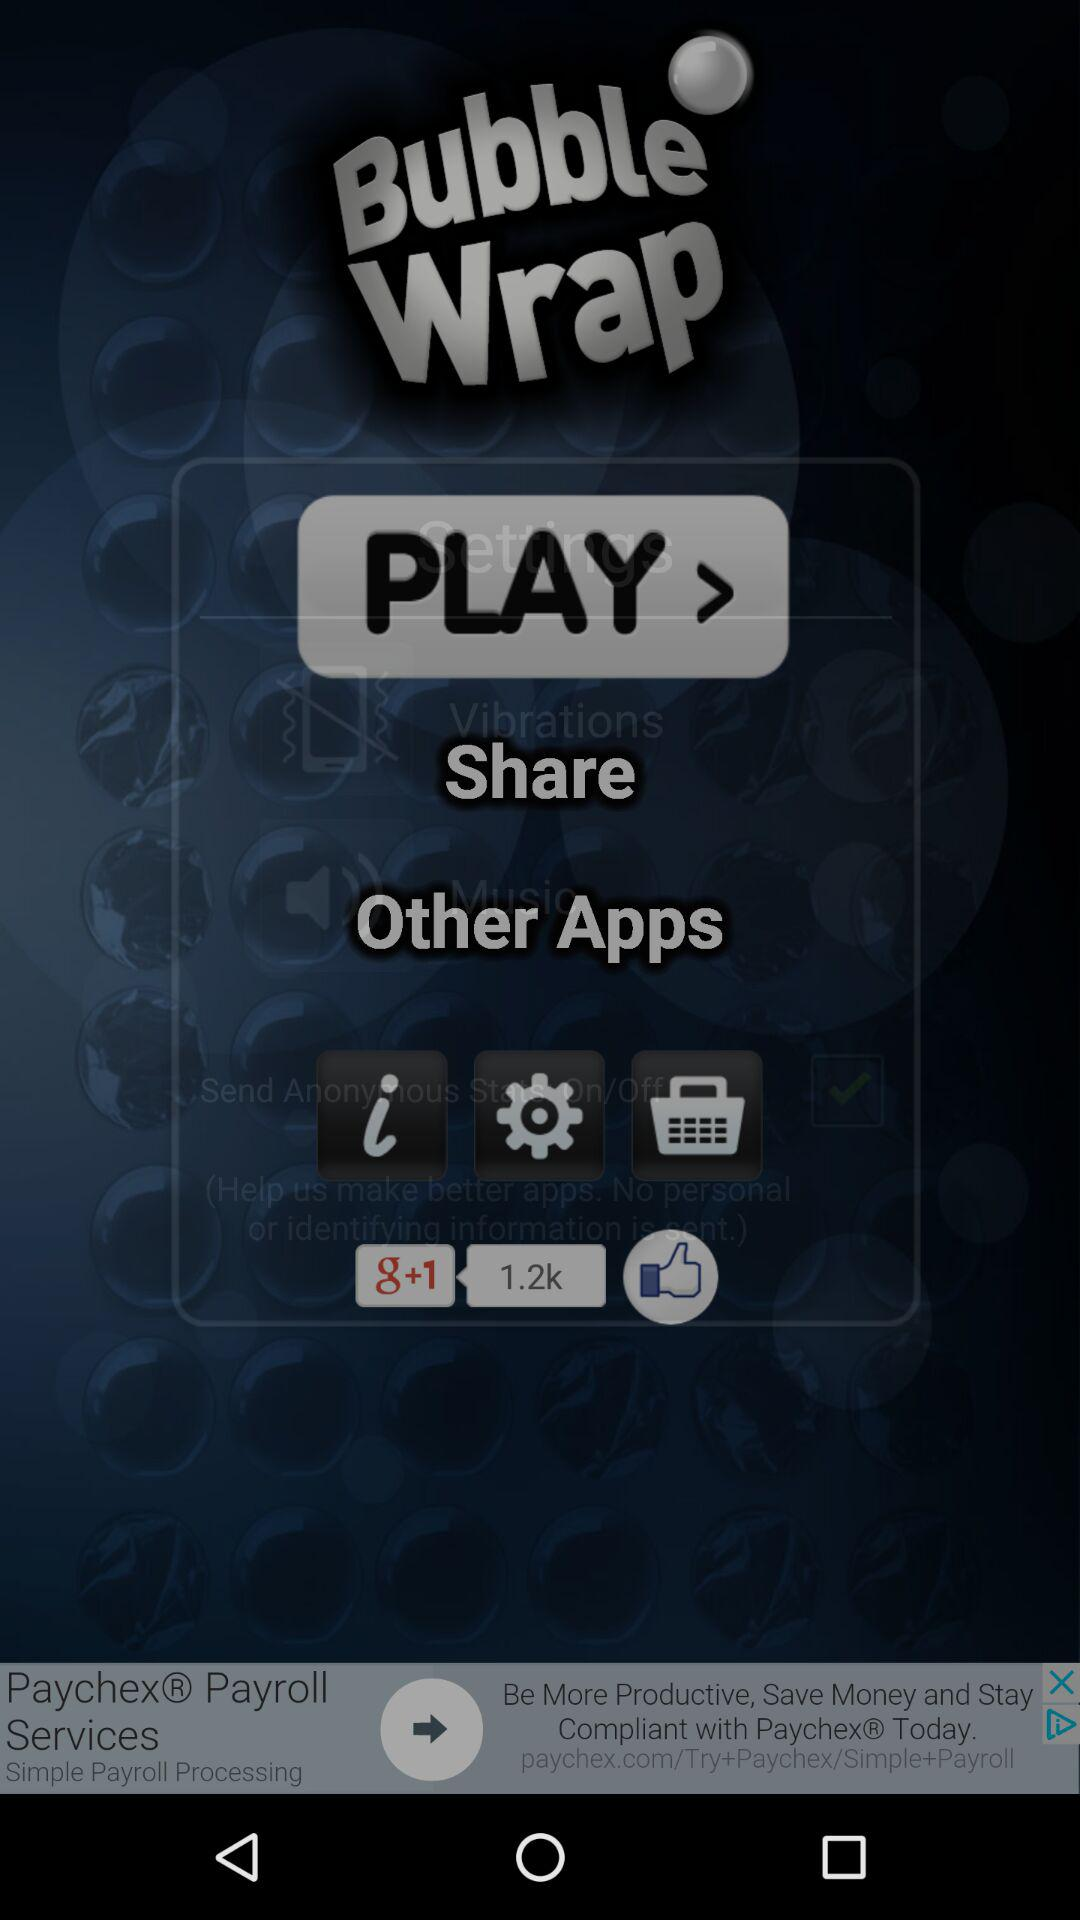What is the name of the application? The name of the application is "Bubble Wrap". 